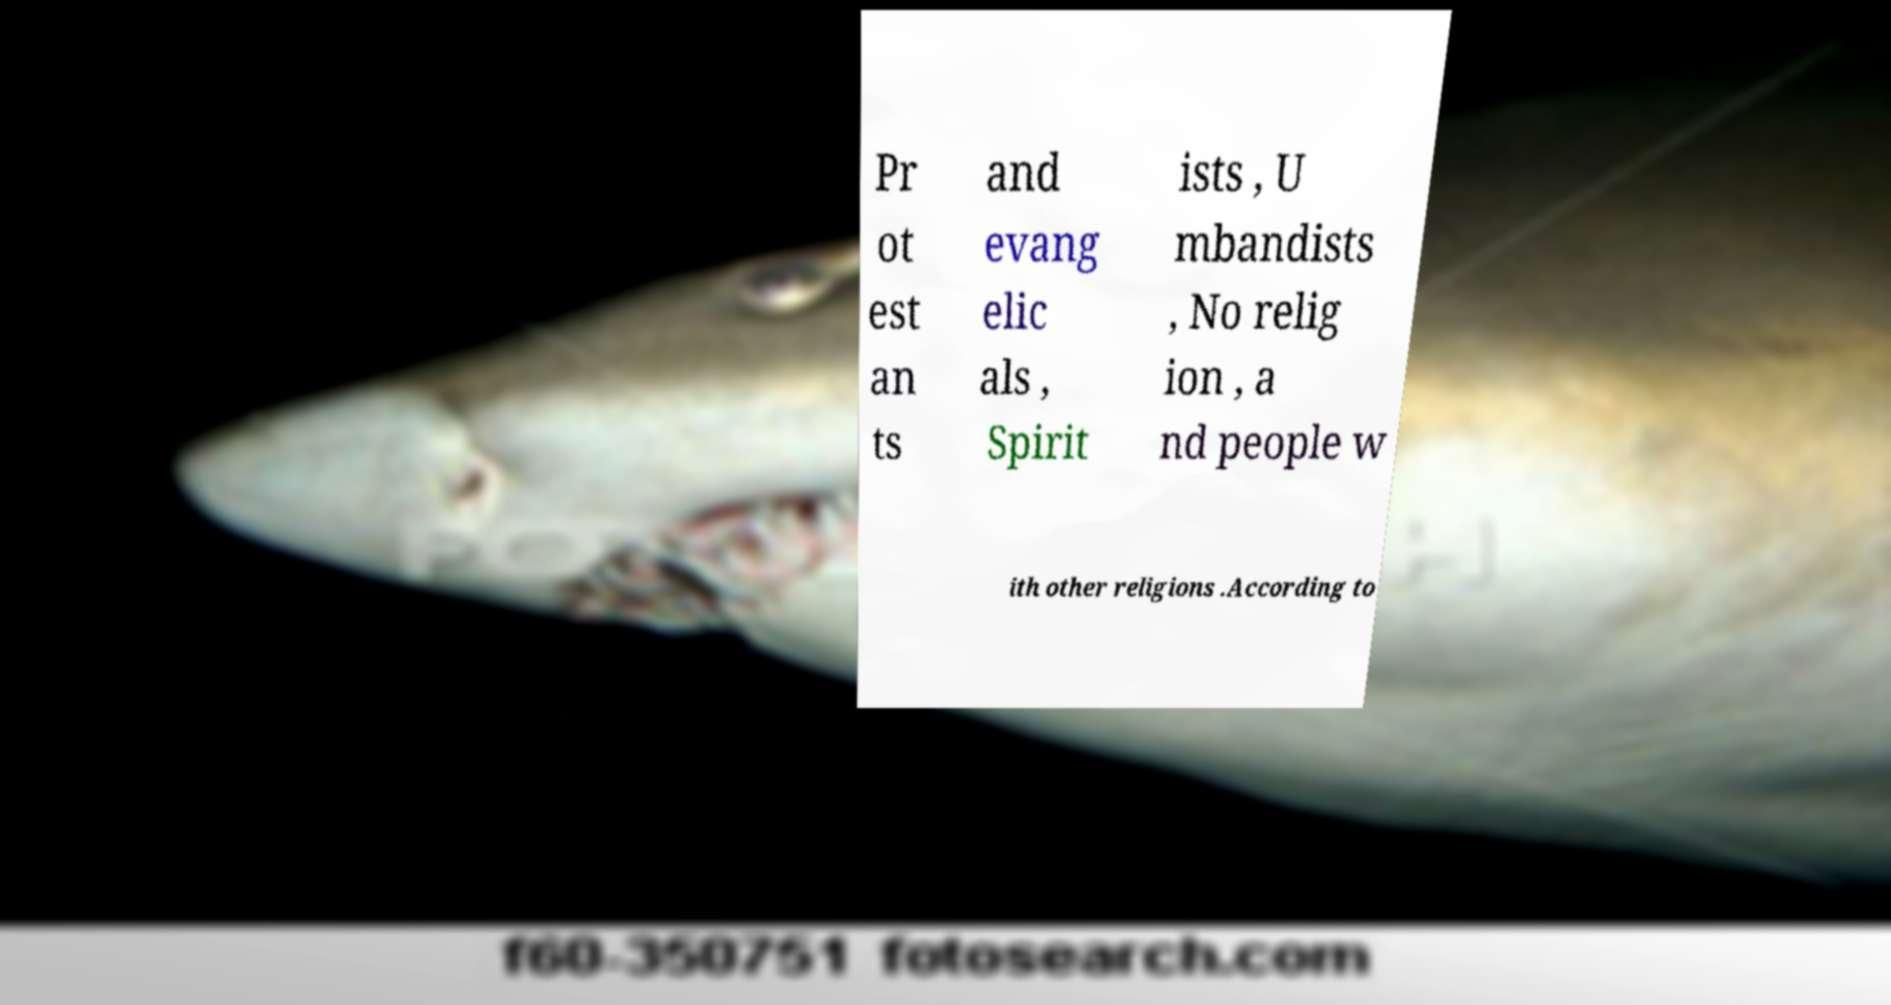Can you accurately transcribe the text from the provided image for me? Pr ot est an ts and evang elic als , Spirit ists , U mbandists , No relig ion , a nd people w ith other religions .According to 